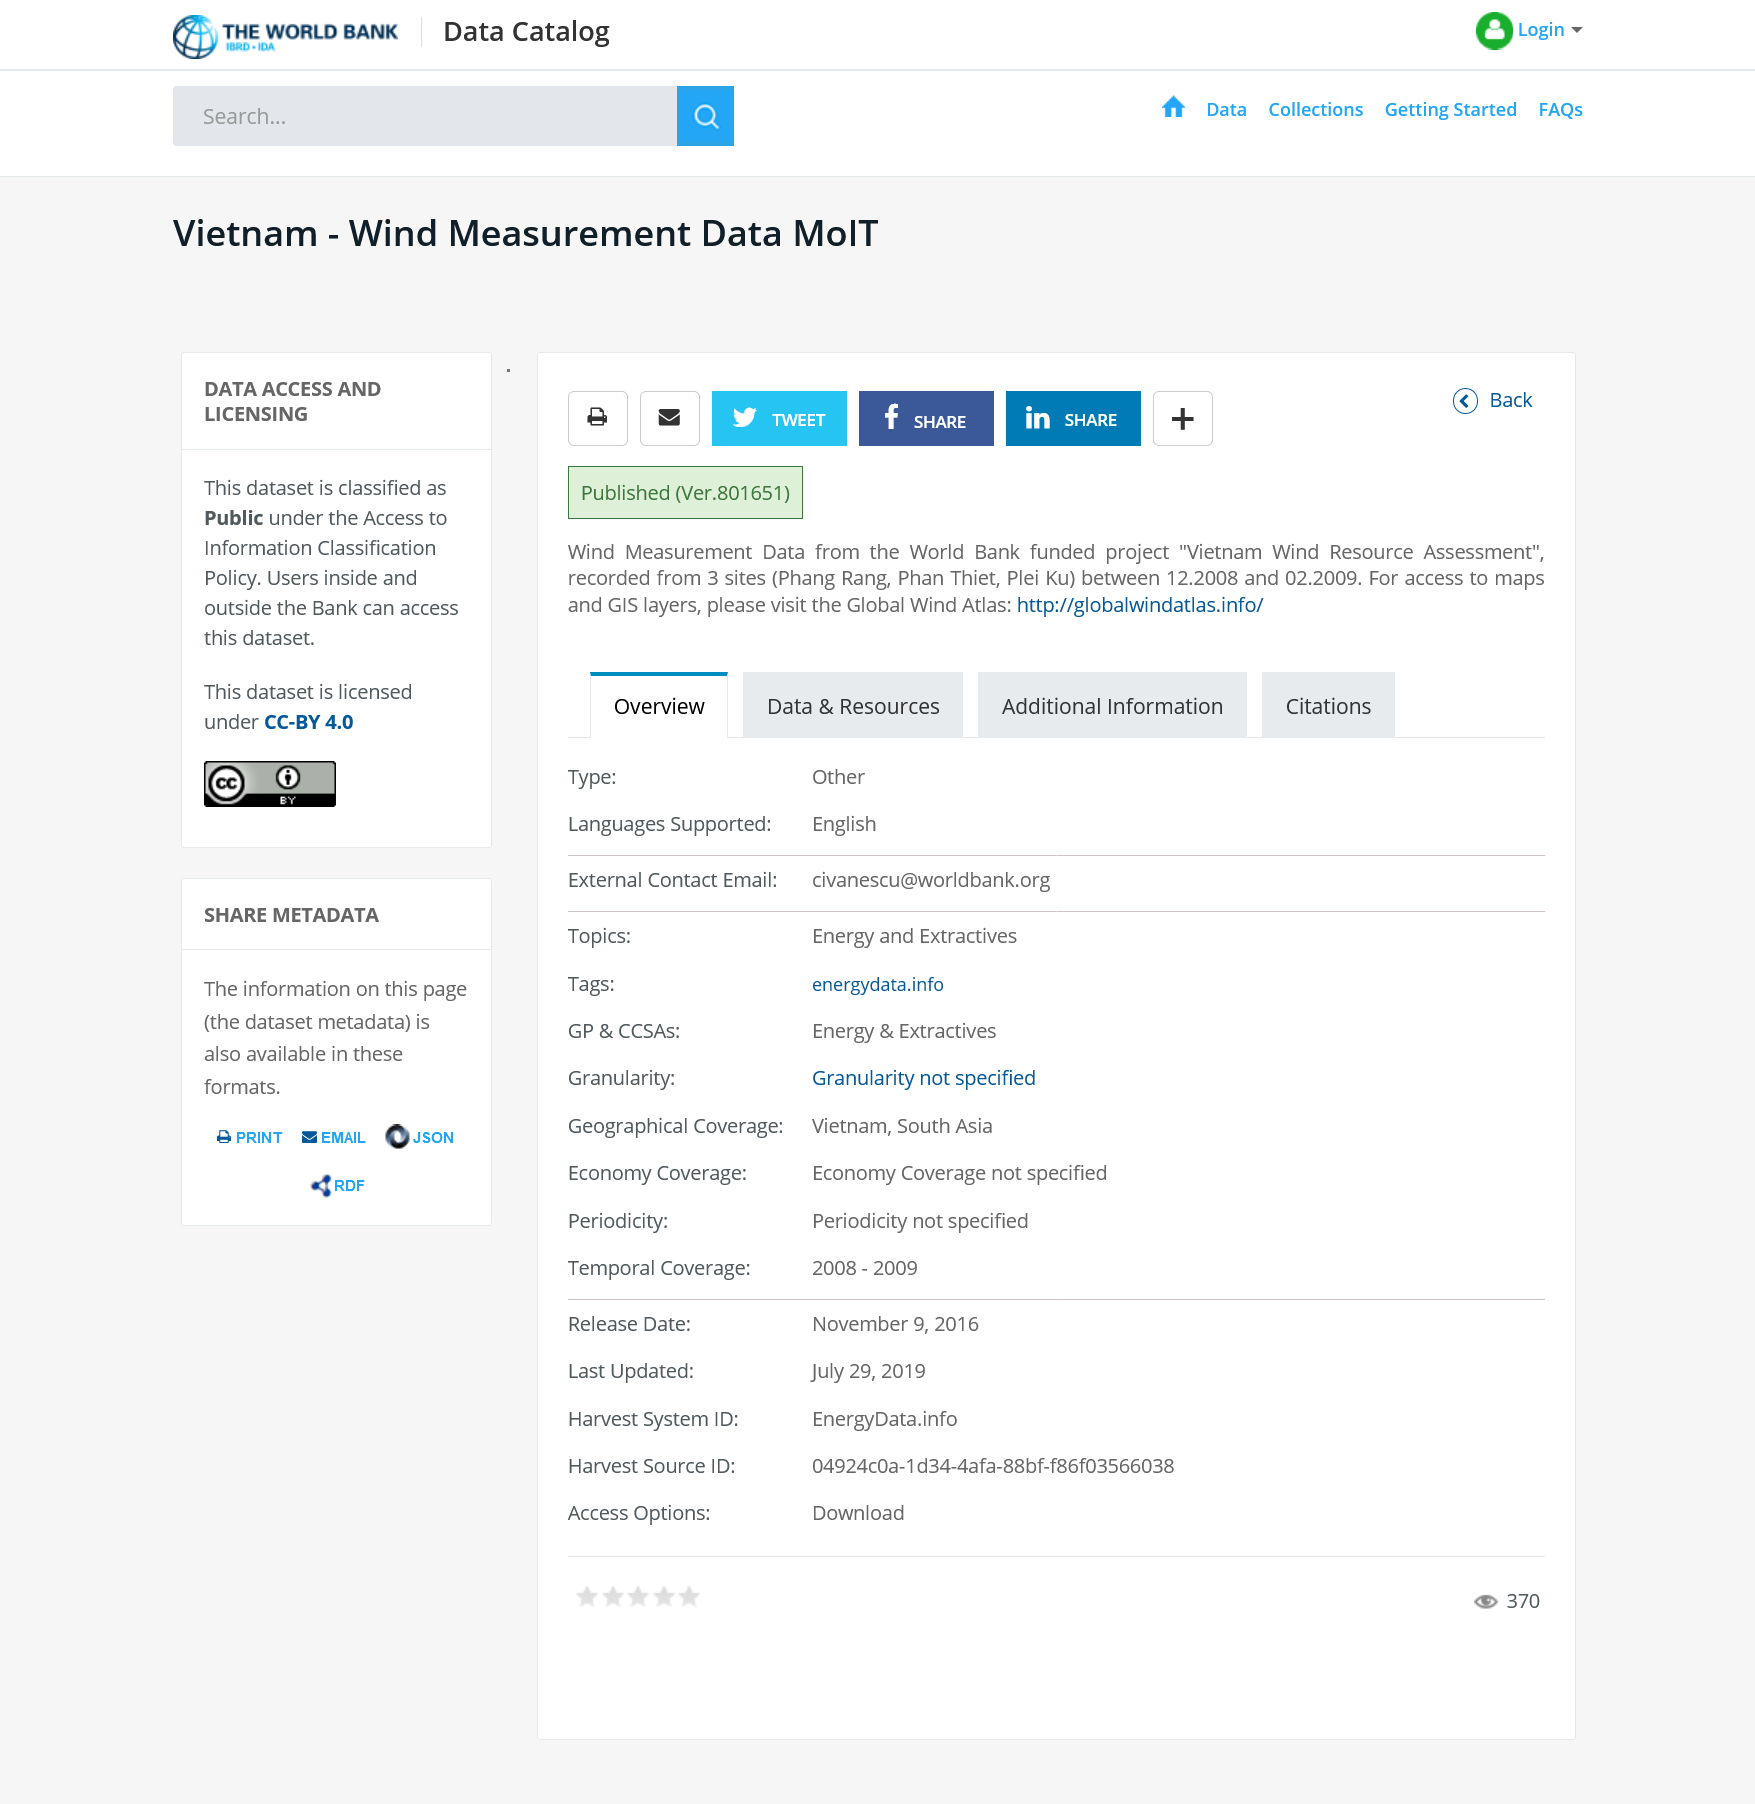Specify some key components in this picture. The dataset is classified as public. The dataset can be accessed by both users within and outside the Bank. Wind measurements are recorded from three sites: Phang Rang, Phan Thiet, and Plei Ku. 